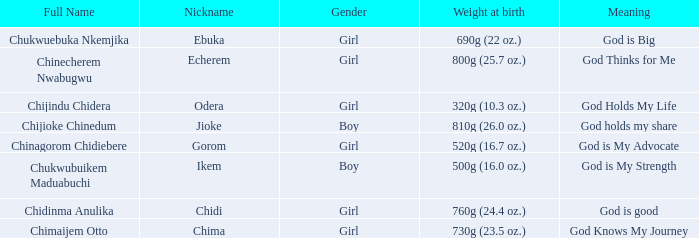What is the nickname of the baby with the birth weight of 730g (23.5 oz.)? Chima. 